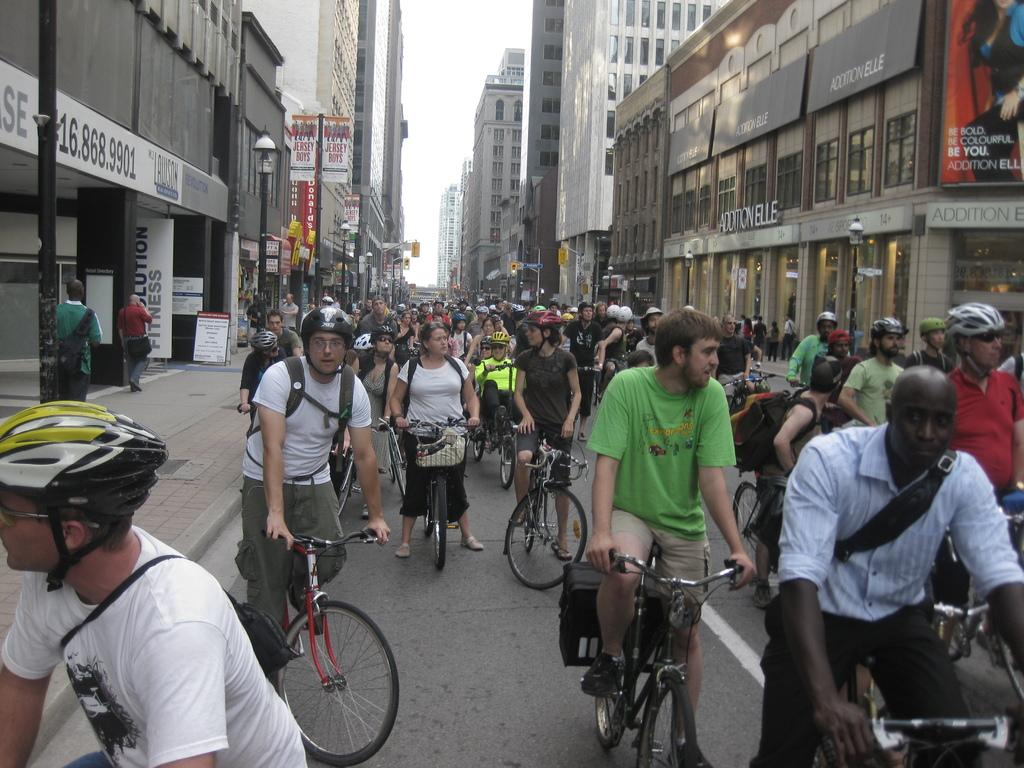Who or what can be seen in the image? There are people in the image. What are the people doing or using in the image? Most of the people are with cycles, and some people are standing on the path. What can be seen in the distance in the image? There are buildings in the background of the image. What type of marble is being used to play a game in the image? There is no marble or game present in the image; it features people with cycles and standing on the path. 